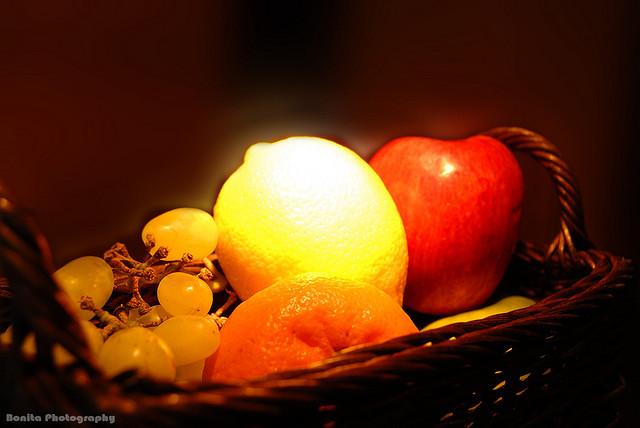Is there a light above the fruits?
Keep it brief. Yes. What is the name of the object on the right side of the bowl?
Be succinct. Apple. What fruit is on the left?
Give a very brief answer. Grapes. How many types of fruit are there in the image?
Be succinct. 4. How many types of fruit are in the image?
Keep it brief. 4. How many apples are there?
Be succinct. 1. What is the fruit in?
Give a very brief answer. Basket. Do these fruits represent a healthy diet?
Write a very short answer. Yes. 